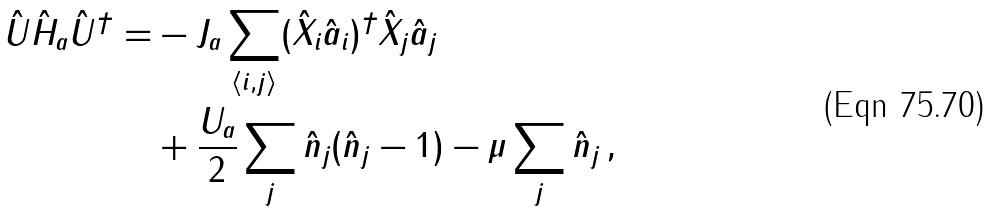Convert formula to latex. <formula><loc_0><loc_0><loc_500><loc_500>\hat { U } \hat { H } _ { a } \hat { U } ^ { \dagger } = & - J _ { a } \sum _ { \langle i , j \rangle } ( \hat { X } _ { i } \hat { a } _ { i } ) ^ { \dagger } \hat { X } _ { j } \hat { a } _ { j } \\ & + \frac { U _ { a } } { 2 } \sum _ { j } \hat { n } _ { j } ( \hat { n } _ { j } - 1 ) - \mu \sum _ { j } \hat { n } _ { j } \, ,</formula> 